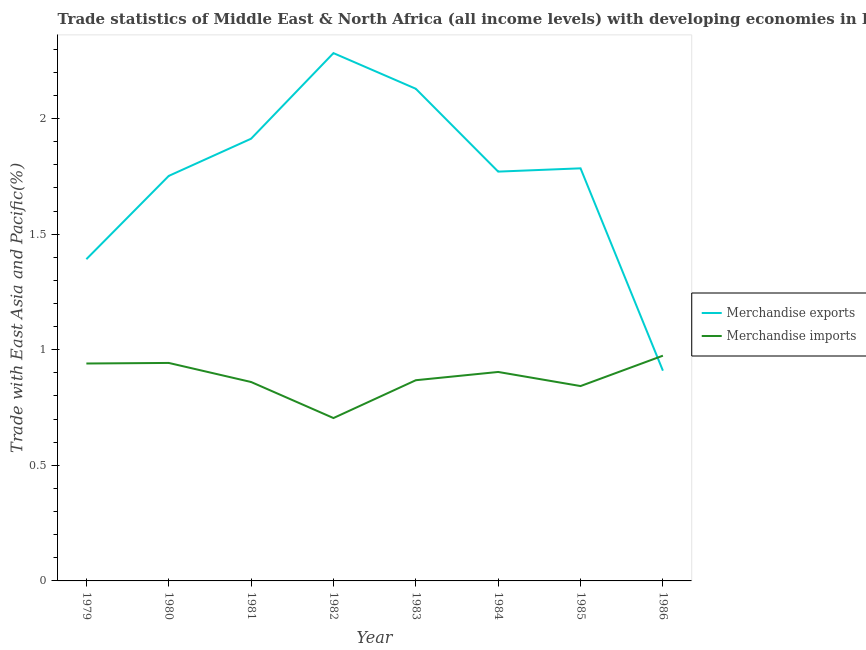Does the line corresponding to merchandise exports intersect with the line corresponding to merchandise imports?
Offer a very short reply. Yes. Is the number of lines equal to the number of legend labels?
Keep it short and to the point. Yes. What is the merchandise imports in 1983?
Give a very brief answer. 0.87. Across all years, what is the maximum merchandise exports?
Keep it short and to the point. 2.28. Across all years, what is the minimum merchandise exports?
Make the answer very short. 0.91. In which year was the merchandise imports minimum?
Give a very brief answer. 1982. What is the total merchandise imports in the graph?
Provide a succinct answer. 7.04. What is the difference between the merchandise imports in 1980 and that in 1985?
Ensure brevity in your answer.  0.1. What is the difference between the merchandise imports in 1985 and the merchandise exports in 1983?
Provide a short and direct response. -1.29. What is the average merchandise exports per year?
Offer a very short reply. 1.74. In the year 1979, what is the difference between the merchandise exports and merchandise imports?
Your answer should be very brief. 0.45. What is the ratio of the merchandise imports in 1979 to that in 1983?
Make the answer very short. 1.08. Is the merchandise exports in 1982 less than that in 1983?
Provide a succinct answer. No. What is the difference between the highest and the second highest merchandise imports?
Your response must be concise. 0.03. What is the difference between the highest and the lowest merchandise exports?
Your answer should be compact. 1.37. In how many years, is the merchandise exports greater than the average merchandise exports taken over all years?
Your answer should be compact. 6. Does the merchandise exports monotonically increase over the years?
Make the answer very short. No. Is the merchandise imports strictly less than the merchandise exports over the years?
Ensure brevity in your answer.  No. How many lines are there?
Keep it short and to the point. 2. What is the difference between two consecutive major ticks on the Y-axis?
Ensure brevity in your answer.  0.5. Are the values on the major ticks of Y-axis written in scientific E-notation?
Offer a terse response. No. Does the graph contain any zero values?
Provide a short and direct response. No. Does the graph contain grids?
Offer a terse response. No. Where does the legend appear in the graph?
Your answer should be very brief. Center right. How many legend labels are there?
Your response must be concise. 2. How are the legend labels stacked?
Your answer should be compact. Vertical. What is the title of the graph?
Offer a very short reply. Trade statistics of Middle East & North Africa (all income levels) with developing economies in East Asia. What is the label or title of the Y-axis?
Offer a very short reply. Trade with East Asia and Pacific(%). What is the Trade with East Asia and Pacific(%) of Merchandise exports in 1979?
Ensure brevity in your answer.  1.39. What is the Trade with East Asia and Pacific(%) in Merchandise imports in 1979?
Offer a terse response. 0.94. What is the Trade with East Asia and Pacific(%) of Merchandise exports in 1980?
Offer a very short reply. 1.75. What is the Trade with East Asia and Pacific(%) of Merchandise imports in 1980?
Make the answer very short. 0.94. What is the Trade with East Asia and Pacific(%) of Merchandise exports in 1981?
Give a very brief answer. 1.91. What is the Trade with East Asia and Pacific(%) in Merchandise imports in 1981?
Offer a terse response. 0.86. What is the Trade with East Asia and Pacific(%) in Merchandise exports in 1982?
Offer a very short reply. 2.28. What is the Trade with East Asia and Pacific(%) of Merchandise imports in 1982?
Ensure brevity in your answer.  0.7. What is the Trade with East Asia and Pacific(%) in Merchandise exports in 1983?
Ensure brevity in your answer.  2.13. What is the Trade with East Asia and Pacific(%) in Merchandise imports in 1983?
Offer a terse response. 0.87. What is the Trade with East Asia and Pacific(%) in Merchandise exports in 1984?
Your answer should be very brief. 1.77. What is the Trade with East Asia and Pacific(%) of Merchandise imports in 1984?
Your answer should be compact. 0.9. What is the Trade with East Asia and Pacific(%) of Merchandise exports in 1985?
Offer a very short reply. 1.78. What is the Trade with East Asia and Pacific(%) in Merchandise imports in 1985?
Your answer should be very brief. 0.84. What is the Trade with East Asia and Pacific(%) of Merchandise exports in 1986?
Offer a terse response. 0.91. What is the Trade with East Asia and Pacific(%) of Merchandise imports in 1986?
Make the answer very short. 0.97. Across all years, what is the maximum Trade with East Asia and Pacific(%) in Merchandise exports?
Offer a very short reply. 2.28. Across all years, what is the maximum Trade with East Asia and Pacific(%) of Merchandise imports?
Ensure brevity in your answer.  0.97. Across all years, what is the minimum Trade with East Asia and Pacific(%) in Merchandise exports?
Provide a short and direct response. 0.91. Across all years, what is the minimum Trade with East Asia and Pacific(%) in Merchandise imports?
Offer a terse response. 0.7. What is the total Trade with East Asia and Pacific(%) of Merchandise exports in the graph?
Ensure brevity in your answer.  13.93. What is the total Trade with East Asia and Pacific(%) in Merchandise imports in the graph?
Your response must be concise. 7.04. What is the difference between the Trade with East Asia and Pacific(%) of Merchandise exports in 1979 and that in 1980?
Offer a terse response. -0.36. What is the difference between the Trade with East Asia and Pacific(%) of Merchandise imports in 1979 and that in 1980?
Provide a short and direct response. -0. What is the difference between the Trade with East Asia and Pacific(%) in Merchandise exports in 1979 and that in 1981?
Give a very brief answer. -0.52. What is the difference between the Trade with East Asia and Pacific(%) of Merchandise imports in 1979 and that in 1981?
Your answer should be compact. 0.08. What is the difference between the Trade with East Asia and Pacific(%) in Merchandise exports in 1979 and that in 1982?
Provide a succinct answer. -0.89. What is the difference between the Trade with East Asia and Pacific(%) in Merchandise imports in 1979 and that in 1982?
Your answer should be compact. 0.24. What is the difference between the Trade with East Asia and Pacific(%) in Merchandise exports in 1979 and that in 1983?
Your answer should be compact. -0.74. What is the difference between the Trade with East Asia and Pacific(%) in Merchandise imports in 1979 and that in 1983?
Keep it short and to the point. 0.07. What is the difference between the Trade with East Asia and Pacific(%) of Merchandise exports in 1979 and that in 1984?
Offer a very short reply. -0.38. What is the difference between the Trade with East Asia and Pacific(%) of Merchandise imports in 1979 and that in 1984?
Provide a short and direct response. 0.04. What is the difference between the Trade with East Asia and Pacific(%) of Merchandise exports in 1979 and that in 1985?
Your response must be concise. -0.39. What is the difference between the Trade with East Asia and Pacific(%) of Merchandise imports in 1979 and that in 1985?
Offer a terse response. 0.1. What is the difference between the Trade with East Asia and Pacific(%) in Merchandise exports in 1979 and that in 1986?
Keep it short and to the point. 0.48. What is the difference between the Trade with East Asia and Pacific(%) in Merchandise imports in 1979 and that in 1986?
Keep it short and to the point. -0.03. What is the difference between the Trade with East Asia and Pacific(%) of Merchandise exports in 1980 and that in 1981?
Provide a short and direct response. -0.16. What is the difference between the Trade with East Asia and Pacific(%) of Merchandise imports in 1980 and that in 1981?
Provide a short and direct response. 0.08. What is the difference between the Trade with East Asia and Pacific(%) of Merchandise exports in 1980 and that in 1982?
Your answer should be compact. -0.53. What is the difference between the Trade with East Asia and Pacific(%) in Merchandise imports in 1980 and that in 1982?
Provide a short and direct response. 0.24. What is the difference between the Trade with East Asia and Pacific(%) of Merchandise exports in 1980 and that in 1983?
Offer a terse response. -0.38. What is the difference between the Trade with East Asia and Pacific(%) in Merchandise imports in 1980 and that in 1983?
Offer a terse response. 0.07. What is the difference between the Trade with East Asia and Pacific(%) of Merchandise exports in 1980 and that in 1984?
Your answer should be very brief. -0.02. What is the difference between the Trade with East Asia and Pacific(%) of Merchandise imports in 1980 and that in 1984?
Your answer should be very brief. 0.04. What is the difference between the Trade with East Asia and Pacific(%) of Merchandise exports in 1980 and that in 1985?
Offer a very short reply. -0.03. What is the difference between the Trade with East Asia and Pacific(%) in Merchandise exports in 1980 and that in 1986?
Provide a short and direct response. 0.84. What is the difference between the Trade with East Asia and Pacific(%) of Merchandise imports in 1980 and that in 1986?
Make the answer very short. -0.03. What is the difference between the Trade with East Asia and Pacific(%) in Merchandise exports in 1981 and that in 1982?
Offer a terse response. -0.37. What is the difference between the Trade with East Asia and Pacific(%) in Merchandise imports in 1981 and that in 1982?
Your answer should be very brief. 0.16. What is the difference between the Trade with East Asia and Pacific(%) in Merchandise exports in 1981 and that in 1983?
Keep it short and to the point. -0.22. What is the difference between the Trade with East Asia and Pacific(%) in Merchandise imports in 1981 and that in 1983?
Your answer should be very brief. -0.01. What is the difference between the Trade with East Asia and Pacific(%) in Merchandise exports in 1981 and that in 1984?
Give a very brief answer. 0.14. What is the difference between the Trade with East Asia and Pacific(%) of Merchandise imports in 1981 and that in 1984?
Your answer should be very brief. -0.04. What is the difference between the Trade with East Asia and Pacific(%) of Merchandise exports in 1981 and that in 1985?
Your response must be concise. 0.13. What is the difference between the Trade with East Asia and Pacific(%) in Merchandise imports in 1981 and that in 1985?
Keep it short and to the point. 0.02. What is the difference between the Trade with East Asia and Pacific(%) of Merchandise imports in 1981 and that in 1986?
Ensure brevity in your answer.  -0.11. What is the difference between the Trade with East Asia and Pacific(%) of Merchandise exports in 1982 and that in 1983?
Keep it short and to the point. 0.15. What is the difference between the Trade with East Asia and Pacific(%) of Merchandise imports in 1982 and that in 1983?
Ensure brevity in your answer.  -0.16. What is the difference between the Trade with East Asia and Pacific(%) in Merchandise exports in 1982 and that in 1984?
Your response must be concise. 0.51. What is the difference between the Trade with East Asia and Pacific(%) of Merchandise imports in 1982 and that in 1984?
Your answer should be compact. -0.2. What is the difference between the Trade with East Asia and Pacific(%) in Merchandise exports in 1982 and that in 1985?
Provide a succinct answer. 0.5. What is the difference between the Trade with East Asia and Pacific(%) of Merchandise imports in 1982 and that in 1985?
Provide a succinct answer. -0.14. What is the difference between the Trade with East Asia and Pacific(%) of Merchandise exports in 1982 and that in 1986?
Make the answer very short. 1.37. What is the difference between the Trade with East Asia and Pacific(%) in Merchandise imports in 1982 and that in 1986?
Offer a terse response. -0.27. What is the difference between the Trade with East Asia and Pacific(%) in Merchandise exports in 1983 and that in 1984?
Keep it short and to the point. 0.36. What is the difference between the Trade with East Asia and Pacific(%) in Merchandise imports in 1983 and that in 1984?
Your answer should be compact. -0.04. What is the difference between the Trade with East Asia and Pacific(%) in Merchandise exports in 1983 and that in 1985?
Your answer should be very brief. 0.34. What is the difference between the Trade with East Asia and Pacific(%) of Merchandise imports in 1983 and that in 1985?
Offer a very short reply. 0.03. What is the difference between the Trade with East Asia and Pacific(%) of Merchandise exports in 1983 and that in 1986?
Provide a succinct answer. 1.22. What is the difference between the Trade with East Asia and Pacific(%) in Merchandise imports in 1983 and that in 1986?
Give a very brief answer. -0.11. What is the difference between the Trade with East Asia and Pacific(%) in Merchandise exports in 1984 and that in 1985?
Your answer should be very brief. -0.01. What is the difference between the Trade with East Asia and Pacific(%) in Merchandise imports in 1984 and that in 1985?
Your response must be concise. 0.06. What is the difference between the Trade with East Asia and Pacific(%) of Merchandise exports in 1984 and that in 1986?
Ensure brevity in your answer.  0.86. What is the difference between the Trade with East Asia and Pacific(%) of Merchandise imports in 1984 and that in 1986?
Offer a terse response. -0.07. What is the difference between the Trade with East Asia and Pacific(%) of Merchandise exports in 1985 and that in 1986?
Provide a short and direct response. 0.88. What is the difference between the Trade with East Asia and Pacific(%) of Merchandise imports in 1985 and that in 1986?
Provide a short and direct response. -0.13. What is the difference between the Trade with East Asia and Pacific(%) in Merchandise exports in 1979 and the Trade with East Asia and Pacific(%) in Merchandise imports in 1980?
Ensure brevity in your answer.  0.45. What is the difference between the Trade with East Asia and Pacific(%) in Merchandise exports in 1979 and the Trade with East Asia and Pacific(%) in Merchandise imports in 1981?
Provide a short and direct response. 0.53. What is the difference between the Trade with East Asia and Pacific(%) in Merchandise exports in 1979 and the Trade with East Asia and Pacific(%) in Merchandise imports in 1982?
Offer a terse response. 0.69. What is the difference between the Trade with East Asia and Pacific(%) in Merchandise exports in 1979 and the Trade with East Asia and Pacific(%) in Merchandise imports in 1983?
Ensure brevity in your answer.  0.52. What is the difference between the Trade with East Asia and Pacific(%) of Merchandise exports in 1979 and the Trade with East Asia and Pacific(%) of Merchandise imports in 1984?
Your answer should be compact. 0.49. What is the difference between the Trade with East Asia and Pacific(%) in Merchandise exports in 1979 and the Trade with East Asia and Pacific(%) in Merchandise imports in 1985?
Provide a short and direct response. 0.55. What is the difference between the Trade with East Asia and Pacific(%) of Merchandise exports in 1979 and the Trade with East Asia and Pacific(%) of Merchandise imports in 1986?
Offer a terse response. 0.42. What is the difference between the Trade with East Asia and Pacific(%) of Merchandise exports in 1980 and the Trade with East Asia and Pacific(%) of Merchandise imports in 1981?
Your answer should be compact. 0.89. What is the difference between the Trade with East Asia and Pacific(%) in Merchandise exports in 1980 and the Trade with East Asia and Pacific(%) in Merchandise imports in 1982?
Give a very brief answer. 1.05. What is the difference between the Trade with East Asia and Pacific(%) of Merchandise exports in 1980 and the Trade with East Asia and Pacific(%) of Merchandise imports in 1983?
Offer a very short reply. 0.88. What is the difference between the Trade with East Asia and Pacific(%) in Merchandise exports in 1980 and the Trade with East Asia and Pacific(%) in Merchandise imports in 1984?
Keep it short and to the point. 0.85. What is the difference between the Trade with East Asia and Pacific(%) of Merchandise exports in 1980 and the Trade with East Asia and Pacific(%) of Merchandise imports in 1985?
Offer a terse response. 0.91. What is the difference between the Trade with East Asia and Pacific(%) of Merchandise exports in 1980 and the Trade with East Asia and Pacific(%) of Merchandise imports in 1986?
Make the answer very short. 0.78. What is the difference between the Trade with East Asia and Pacific(%) in Merchandise exports in 1981 and the Trade with East Asia and Pacific(%) in Merchandise imports in 1982?
Give a very brief answer. 1.21. What is the difference between the Trade with East Asia and Pacific(%) of Merchandise exports in 1981 and the Trade with East Asia and Pacific(%) of Merchandise imports in 1983?
Your response must be concise. 1.04. What is the difference between the Trade with East Asia and Pacific(%) in Merchandise exports in 1981 and the Trade with East Asia and Pacific(%) in Merchandise imports in 1984?
Provide a succinct answer. 1.01. What is the difference between the Trade with East Asia and Pacific(%) of Merchandise exports in 1981 and the Trade with East Asia and Pacific(%) of Merchandise imports in 1985?
Your answer should be compact. 1.07. What is the difference between the Trade with East Asia and Pacific(%) of Merchandise exports in 1981 and the Trade with East Asia and Pacific(%) of Merchandise imports in 1986?
Your response must be concise. 0.94. What is the difference between the Trade with East Asia and Pacific(%) in Merchandise exports in 1982 and the Trade with East Asia and Pacific(%) in Merchandise imports in 1983?
Give a very brief answer. 1.41. What is the difference between the Trade with East Asia and Pacific(%) in Merchandise exports in 1982 and the Trade with East Asia and Pacific(%) in Merchandise imports in 1984?
Offer a terse response. 1.38. What is the difference between the Trade with East Asia and Pacific(%) in Merchandise exports in 1982 and the Trade with East Asia and Pacific(%) in Merchandise imports in 1985?
Offer a terse response. 1.44. What is the difference between the Trade with East Asia and Pacific(%) in Merchandise exports in 1982 and the Trade with East Asia and Pacific(%) in Merchandise imports in 1986?
Provide a succinct answer. 1.31. What is the difference between the Trade with East Asia and Pacific(%) in Merchandise exports in 1983 and the Trade with East Asia and Pacific(%) in Merchandise imports in 1984?
Offer a terse response. 1.22. What is the difference between the Trade with East Asia and Pacific(%) of Merchandise exports in 1983 and the Trade with East Asia and Pacific(%) of Merchandise imports in 1985?
Offer a terse response. 1.29. What is the difference between the Trade with East Asia and Pacific(%) of Merchandise exports in 1983 and the Trade with East Asia and Pacific(%) of Merchandise imports in 1986?
Offer a very short reply. 1.15. What is the difference between the Trade with East Asia and Pacific(%) in Merchandise exports in 1984 and the Trade with East Asia and Pacific(%) in Merchandise imports in 1985?
Give a very brief answer. 0.93. What is the difference between the Trade with East Asia and Pacific(%) in Merchandise exports in 1984 and the Trade with East Asia and Pacific(%) in Merchandise imports in 1986?
Offer a very short reply. 0.8. What is the difference between the Trade with East Asia and Pacific(%) in Merchandise exports in 1985 and the Trade with East Asia and Pacific(%) in Merchandise imports in 1986?
Make the answer very short. 0.81. What is the average Trade with East Asia and Pacific(%) of Merchandise exports per year?
Your answer should be very brief. 1.74. What is the average Trade with East Asia and Pacific(%) in Merchandise imports per year?
Your answer should be very brief. 0.88. In the year 1979, what is the difference between the Trade with East Asia and Pacific(%) in Merchandise exports and Trade with East Asia and Pacific(%) in Merchandise imports?
Keep it short and to the point. 0.45. In the year 1980, what is the difference between the Trade with East Asia and Pacific(%) of Merchandise exports and Trade with East Asia and Pacific(%) of Merchandise imports?
Provide a succinct answer. 0.81. In the year 1981, what is the difference between the Trade with East Asia and Pacific(%) in Merchandise exports and Trade with East Asia and Pacific(%) in Merchandise imports?
Ensure brevity in your answer.  1.05. In the year 1982, what is the difference between the Trade with East Asia and Pacific(%) in Merchandise exports and Trade with East Asia and Pacific(%) in Merchandise imports?
Ensure brevity in your answer.  1.58. In the year 1983, what is the difference between the Trade with East Asia and Pacific(%) of Merchandise exports and Trade with East Asia and Pacific(%) of Merchandise imports?
Offer a terse response. 1.26. In the year 1984, what is the difference between the Trade with East Asia and Pacific(%) in Merchandise exports and Trade with East Asia and Pacific(%) in Merchandise imports?
Offer a terse response. 0.87. In the year 1985, what is the difference between the Trade with East Asia and Pacific(%) of Merchandise exports and Trade with East Asia and Pacific(%) of Merchandise imports?
Keep it short and to the point. 0.94. In the year 1986, what is the difference between the Trade with East Asia and Pacific(%) of Merchandise exports and Trade with East Asia and Pacific(%) of Merchandise imports?
Offer a very short reply. -0.06. What is the ratio of the Trade with East Asia and Pacific(%) of Merchandise exports in 1979 to that in 1980?
Give a very brief answer. 0.79. What is the ratio of the Trade with East Asia and Pacific(%) of Merchandise imports in 1979 to that in 1980?
Make the answer very short. 1. What is the ratio of the Trade with East Asia and Pacific(%) of Merchandise exports in 1979 to that in 1981?
Provide a succinct answer. 0.73. What is the ratio of the Trade with East Asia and Pacific(%) in Merchandise imports in 1979 to that in 1981?
Make the answer very short. 1.09. What is the ratio of the Trade with East Asia and Pacific(%) of Merchandise exports in 1979 to that in 1982?
Your answer should be very brief. 0.61. What is the ratio of the Trade with East Asia and Pacific(%) in Merchandise imports in 1979 to that in 1982?
Make the answer very short. 1.33. What is the ratio of the Trade with East Asia and Pacific(%) in Merchandise exports in 1979 to that in 1983?
Give a very brief answer. 0.65. What is the ratio of the Trade with East Asia and Pacific(%) in Merchandise imports in 1979 to that in 1983?
Offer a terse response. 1.08. What is the ratio of the Trade with East Asia and Pacific(%) in Merchandise exports in 1979 to that in 1984?
Make the answer very short. 0.79. What is the ratio of the Trade with East Asia and Pacific(%) of Merchandise imports in 1979 to that in 1984?
Your answer should be very brief. 1.04. What is the ratio of the Trade with East Asia and Pacific(%) of Merchandise exports in 1979 to that in 1985?
Offer a very short reply. 0.78. What is the ratio of the Trade with East Asia and Pacific(%) in Merchandise imports in 1979 to that in 1985?
Ensure brevity in your answer.  1.12. What is the ratio of the Trade with East Asia and Pacific(%) of Merchandise exports in 1979 to that in 1986?
Provide a short and direct response. 1.53. What is the ratio of the Trade with East Asia and Pacific(%) of Merchandise imports in 1979 to that in 1986?
Provide a succinct answer. 0.97. What is the ratio of the Trade with East Asia and Pacific(%) of Merchandise exports in 1980 to that in 1981?
Ensure brevity in your answer.  0.92. What is the ratio of the Trade with East Asia and Pacific(%) in Merchandise imports in 1980 to that in 1981?
Your answer should be compact. 1.1. What is the ratio of the Trade with East Asia and Pacific(%) in Merchandise exports in 1980 to that in 1982?
Your answer should be very brief. 0.77. What is the ratio of the Trade with East Asia and Pacific(%) of Merchandise imports in 1980 to that in 1982?
Offer a terse response. 1.34. What is the ratio of the Trade with East Asia and Pacific(%) in Merchandise exports in 1980 to that in 1983?
Ensure brevity in your answer.  0.82. What is the ratio of the Trade with East Asia and Pacific(%) in Merchandise imports in 1980 to that in 1983?
Your answer should be compact. 1.09. What is the ratio of the Trade with East Asia and Pacific(%) of Merchandise exports in 1980 to that in 1984?
Offer a terse response. 0.99. What is the ratio of the Trade with East Asia and Pacific(%) in Merchandise imports in 1980 to that in 1984?
Your answer should be compact. 1.04. What is the ratio of the Trade with East Asia and Pacific(%) in Merchandise exports in 1980 to that in 1985?
Keep it short and to the point. 0.98. What is the ratio of the Trade with East Asia and Pacific(%) in Merchandise imports in 1980 to that in 1985?
Keep it short and to the point. 1.12. What is the ratio of the Trade with East Asia and Pacific(%) in Merchandise exports in 1980 to that in 1986?
Provide a succinct answer. 1.93. What is the ratio of the Trade with East Asia and Pacific(%) of Merchandise imports in 1980 to that in 1986?
Give a very brief answer. 0.97. What is the ratio of the Trade with East Asia and Pacific(%) of Merchandise exports in 1981 to that in 1982?
Provide a short and direct response. 0.84. What is the ratio of the Trade with East Asia and Pacific(%) in Merchandise imports in 1981 to that in 1982?
Offer a very short reply. 1.22. What is the ratio of the Trade with East Asia and Pacific(%) of Merchandise exports in 1981 to that in 1983?
Your answer should be very brief. 0.9. What is the ratio of the Trade with East Asia and Pacific(%) in Merchandise exports in 1981 to that in 1984?
Make the answer very short. 1.08. What is the ratio of the Trade with East Asia and Pacific(%) in Merchandise exports in 1981 to that in 1985?
Your response must be concise. 1.07. What is the ratio of the Trade with East Asia and Pacific(%) in Merchandise imports in 1981 to that in 1985?
Your answer should be compact. 1.02. What is the ratio of the Trade with East Asia and Pacific(%) in Merchandise exports in 1981 to that in 1986?
Offer a very short reply. 2.1. What is the ratio of the Trade with East Asia and Pacific(%) of Merchandise imports in 1981 to that in 1986?
Offer a terse response. 0.88. What is the ratio of the Trade with East Asia and Pacific(%) of Merchandise exports in 1982 to that in 1983?
Offer a terse response. 1.07. What is the ratio of the Trade with East Asia and Pacific(%) in Merchandise imports in 1982 to that in 1983?
Your response must be concise. 0.81. What is the ratio of the Trade with East Asia and Pacific(%) of Merchandise exports in 1982 to that in 1984?
Make the answer very short. 1.29. What is the ratio of the Trade with East Asia and Pacific(%) in Merchandise imports in 1982 to that in 1984?
Your answer should be very brief. 0.78. What is the ratio of the Trade with East Asia and Pacific(%) of Merchandise exports in 1982 to that in 1985?
Provide a short and direct response. 1.28. What is the ratio of the Trade with East Asia and Pacific(%) of Merchandise imports in 1982 to that in 1985?
Your answer should be compact. 0.84. What is the ratio of the Trade with East Asia and Pacific(%) in Merchandise exports in 1982 to that in 1986?
Offer a very short reply. 2.51. What is the ratio of the Trade with East Asia and Pacific(%) of Merchandise imports in 1982 to that in 1986?
Offer a terse response. 0.72. What is the ratio of the Trade with East Asia and Pacific(%) in Merchandise exports in 1983 to that in 1984?
Provide a short and direct response. 1.2. What is the ratio of the Trade with East Asia and Pacific(%) of Merchandise imports in 1983 to that in 1984?
Offer a terse response. 0.96. What is the ratio of the Trade with East Asia and Pacific(%) of Merchandise exports in 1983 to that in 1985?
Your response must be concise. 1.19. What is the ratio of the Trade with East Asia and Pacific(%) in Merchandise imports in 1983 to that in 1985?
Provide a succinct answer. 1.03. What is the ratio of the Trade with East Asia and Pacific(%) of Merchandise exports in 1983 to that in 1986?
Provide a succinct answer. 2.34. What is the ratio of the Trade with East Asia and Pacific(%) in Merchandise imports in 1983 to that in 1986?
Your answer should be compact. 0.89. What is the ratio of the Trade with East Asia and Pacific(%) in Merchandise exports in 1984 to that in 1985?
Provide a short and direct response. 0.99. What is the ratio of the Trade with East Asia and Pacific(%) of Merchandise imports in 1984 to that in 1985?
Make the answer very short. 1.07. What is the ratio of the Trade with East Asia and Pacific(%) of Merchandise exports in 1984 to that in 1986?
Offer a very short reply. 1.95. What is the ratio of the Trade with East Asia and Pacific(%) of Merchandise imports in 1984 to that in 1986?
Make the answer very short. 0.93. What is the ratio of the Trade with East Asia and Pacific(%) in Merchandise exports in 1985 to that in 1986?
Offer a terse response. 1.96. What is the ratio of the Trade with East Asia and Pacific(%) of Merchandise imports in 1985 to that in 1986?
Offer a terse response. 0.87. What is the difference between the highest and the second highest Trade with East Asia and Pacific(%) in Merchandise exports?
Offer a very short reply. 0.15. What is the difference between the highest and the second highest Trade with East Asia and Pacific(%) of Merchandise imports?
Your response must be concise. 0.03. What is the difference between the highest and the lowest Trade with East Asia and Pacific(%) of Merchandise exports?
Your response must be concise. 1.37. What is the difference between the highest and the lowest Trade with East Asia and Pacific(%) in Merchandise imports?
Ensure brevity in your answer.  0.27. 